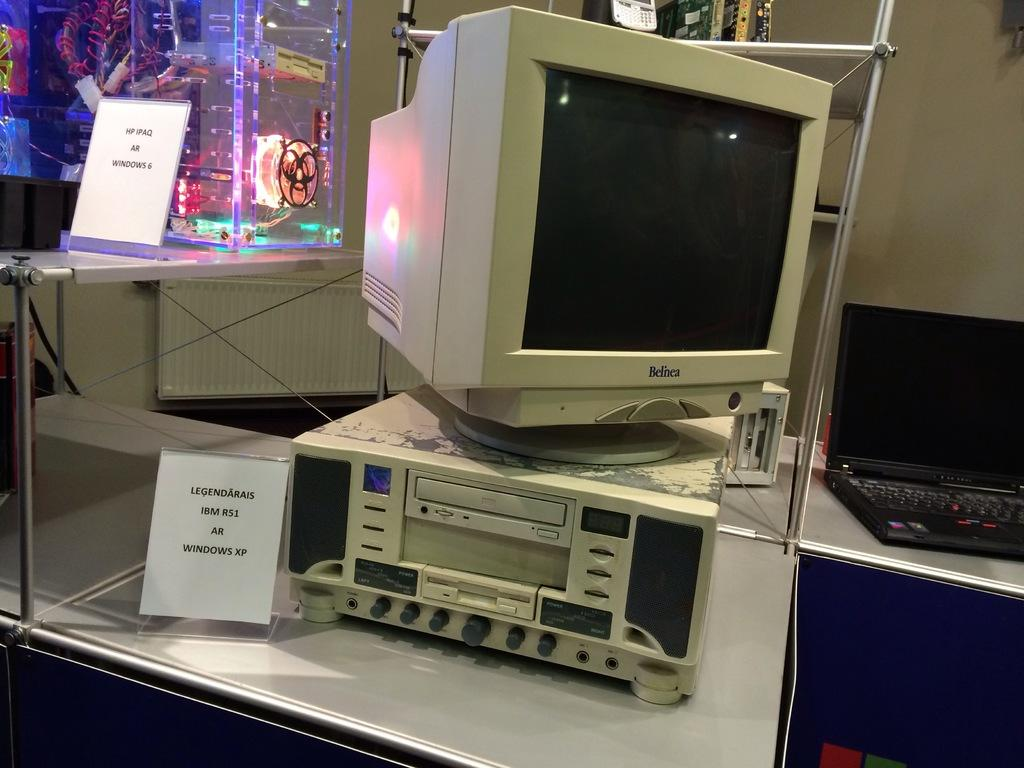<image>
Render a clear and concise summary of the photo. a Belnea computer that has a black screen on it 